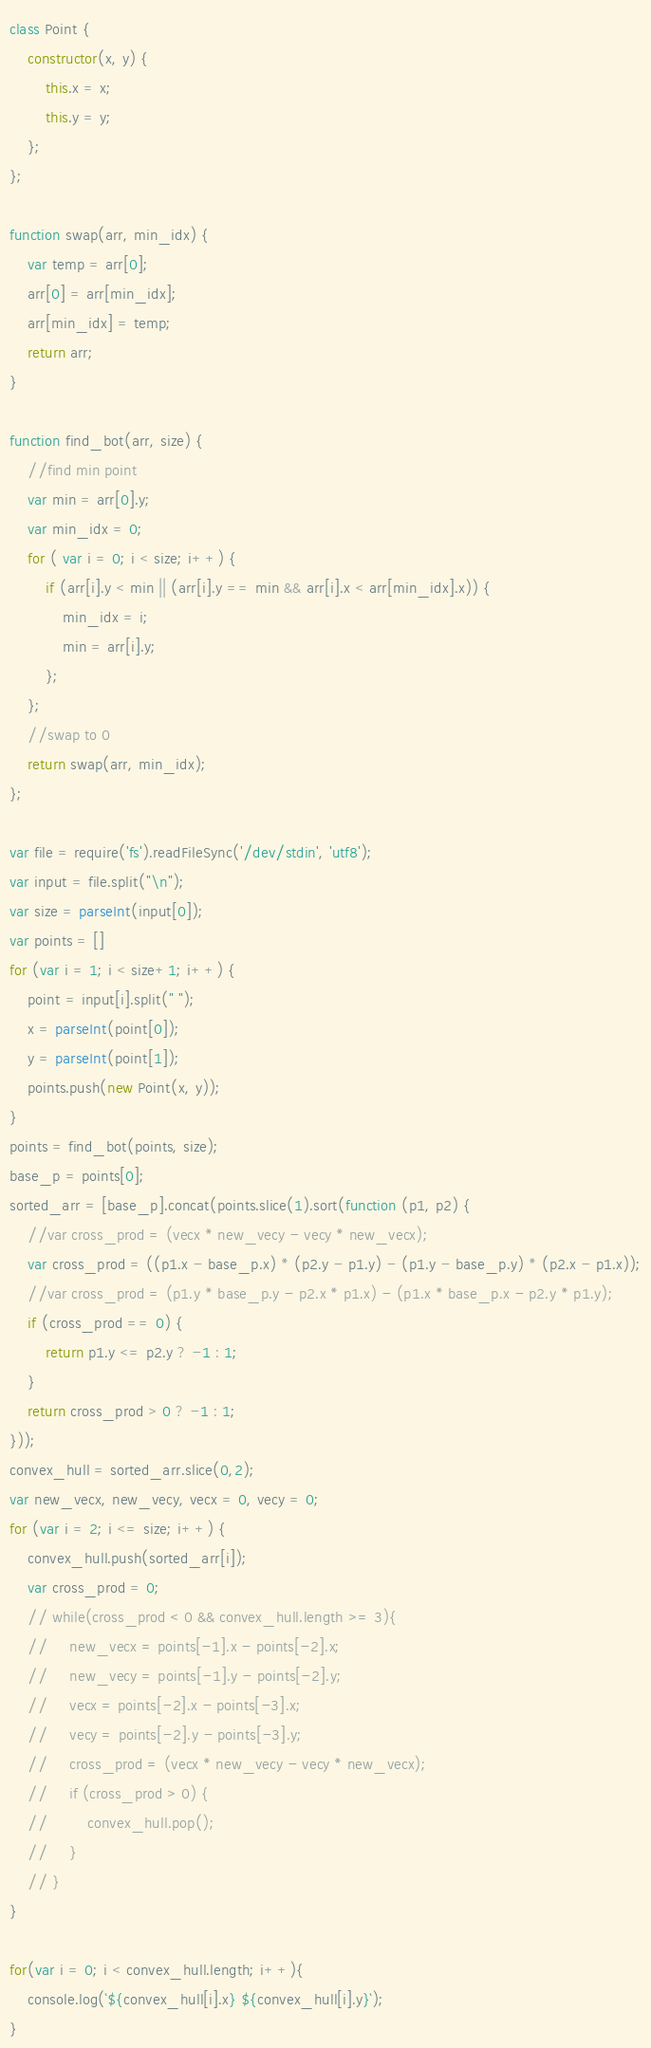Convert code to text. <code><loc_0><loc_0><loc_500><loc_500><_JavaScript_>class Point {
    constructor(x, y) {
        this.x = x;
        this.y = y;
    };
};

function swap(arr, min_idx) {
    var temp = arr[0];
    arr[0] = arr[min_idx];
    arr[min_idx] = temp;
    return arr;
}

function find_bot(arr, size) {
    //find min point
    var min = arr[0].y;
    var min_idx = 0;
    for ( var i = 0; i < size; i++) {
        if (arr[i].y < min || (arr[i].y == min && arr[i].x < arr[min_idx].x)) {
            min_idx = i;
            min = arr[i].y;
        };
    };
    //swap to 0
    return swap(arr, min_idx);
};

var file = require('fs').readFileSync('/dev/stdin', 'utf8');
var input = file.split("\n");
var size = parseInt(input[0]);
var points = []
for (var i = 1; i < size+1; i++) {
    point = input[i].split(" ");
    x = parseInt(point[0]);
    y = parseInt(point[1]);
    points.push(new Point(x, y));
}
points = find_bot(points, size);
base_p = points[0];
sorted_arr = [base_p].concat(points.slice(1).sort(function (p1, p2) {
    //var cross_prod = (vecx * new_vecy - vecy * new_vecx);
    var cross_prod = ((p1.x - base_p.x) * (p2.y - p1.y) - (p1.y - base_p.y) * (p2.x - p1.x));
    //var cross_prod = (p1.y * base_p.y - p2.x * p1.x) - (p1.x * base_p.x - p2.y * p1.y);
    if (cross_prod == 0) {
        return p1.y <= p2.y ? -1 : 1;
    }
    return cross_prod > 0 ? -1 : 1;
}));
convex_hull = sorted_arr.slice(0,2);
var new_vecx, new_vecy, vecx = 0, vecy = 0;
for (var i = 2; i <= size; i++) {
    convex_hull.push(sorted_arr[i]);
    var cross_prod = 0;
    // while(cross_prod < 0 && convex_hull.length >= 3){
    //     new_vecx = points[-1].x - points[-2].x;
    //     new_vecy = points[-1].y - points[-2].y;
    //     vecx = points[-2].x - points[-3].x;
    //     vecy = points[-2].y - points[-3].y;
    //     cross_prod = (vecx * new_vecy - vecy * new_vecx);
    //     if (cross_prod > 0) {
    //         convex_hull.pop();
    //     }
    // }
}

for(var i = 0; i < convex_hull.length; i++){
    console.log(`${convex_hull[i].x} ${convex_hull[i].y}`);
}



</code> 